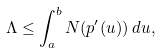<formula> <loc_0><loc_0><loc_500><loc_500>\Lambda \leq \int _ { a } ^ { b } N ( p ^ { \prime } ( u ) ) \, d u ,</formula> 